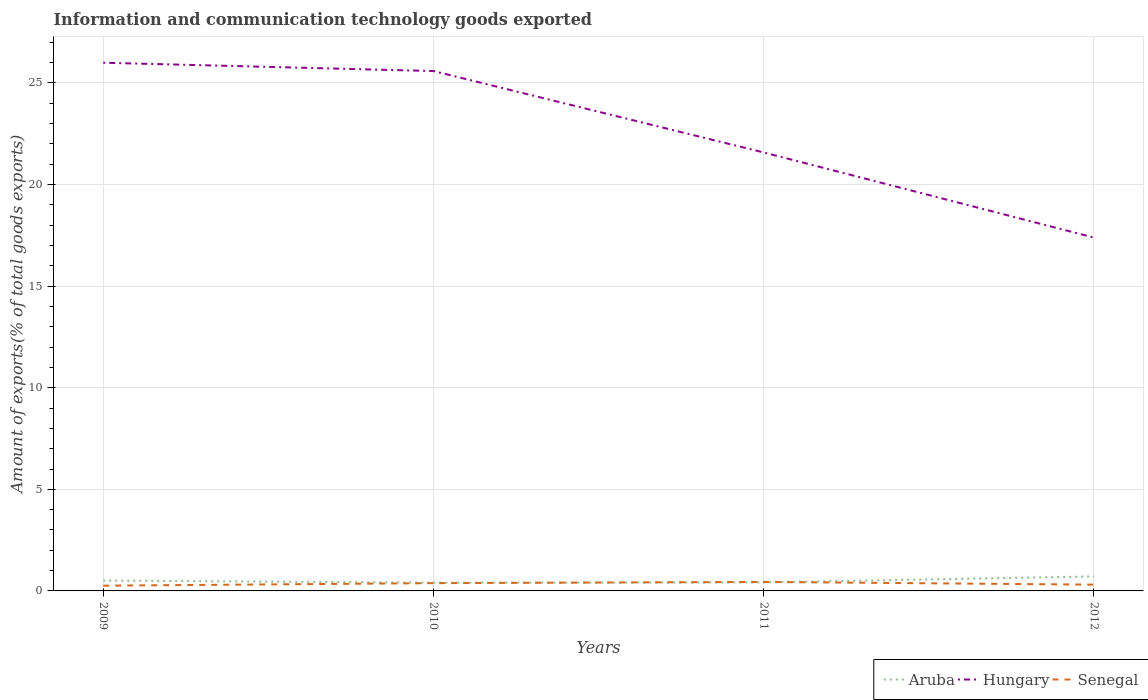How many different coloured lines are there?
Your response must be concise. 3. Does the line corresponding to Aruba intersect with the line corresponding to Hungary?
Ensure brevity in your answer.  No. Is the number of lines equal to the number of legend labels?
Offer a terse response. Yes. Across all years, what is the maximum amount of goods exported in Senegal?
Keep it short and to the point. 0.26. In which year was the amount of goods exported in Senegal maximum?
Ensure brevity in your answer.  2009. What is the total amount of goods exported in Hungary in the graph?
Make the answer very short. 0.41. What is the difference between the highest and the second highest amount of goods exported in Senegal?
Your answer should be compact. 0.18. What is the difference between the highest and the lowest amount of goods exported in Hungary?
Offer a very short reply. 2. How many years are there in the graph?
Your answer should be compact. 4. Does the graph contain any zero values?
Offer a terse response. No. Where does the legend appear in the graph?
Your answer should be compact. Bottom right. How are the legend labels stacked?
Offer a very short reply. Horizontal. What is the title of the graph?
Offer a terse response. Information and communication technology goods exported. What is the label or title of the Y-axis?
Your response must be concise. Amount of exports(% of total goods exports). What is the Amount of exports(% of total goods exports) in Aruba in 2009?
Provide a short and direct response. 0.51. What is the Amount of exports(% of total goods exports) of Hungary in 2009?
Your answer should be compact. 26. What is the Amount of exports(% of total goods exports) in Senegal in 2009?
Make the answer very short. 0.26. What is the Amount of exports(% of total goods exports) in Aruba in 2010?
Offer a very short reply. 0.4. What is the Amount of exports(% of total goods exports) of Hungary in 2010?
Ensure brevity in your answer.  25.59. What is the Amount of exports(% of total goods exports) of Senegal in 2010?
Make the answer very short. 0.38. What is the Amount of exports(% of total goods exports) in Aruba in 2011?
Your answer should be very brief. 0.42. What is the Amount of exports(% of total goods exports) of Hungary in 2011?
Provide a short and direct response. 21.58. What is the Amount of exports(% of total goods exports) of Senegal in 2011?
Your answer should be very brief. 0.44. What is the Amount of exports(% of total goods exports) of Aruba in 2012?
Provide a succinct answer. 0.71. What is the Amount of exports(% of total goods exports) of Hungary in 2012?
Your answer should be compact. 17.39. What is the Amount of exports(% of total goods exports) of Senegal in 2012?
Provide a short and direct response. 0.31. Across all years, what is the maximum Amount of exports(% of total goods exports) in Aruba?
Your answer should be very brief. 0.71. Across all years, what is the maximum Amount of exports(% of total goods exports) of Hungary?
Your answer should be very brief. 26. Across all years, what is the maximum Amount of exports(% of total goods exports) in Senegal?
Your response must be concise. 0.44. Across all years, what is the minimum Amount of exports(% of total goods exports) of Aruba?
Provide a short and direct response. 0.4. Across all years, what is the minimum Amount of exports(% of total goods exports) in Hungary?
Provide a succinct answer. 17.39. Across all years, what is the minimum Amount of exports(% of total goods exports) in Senegal?
Provide a short and direct response. 0.26. What is the total Amount of exports(% of total goods exports) of Aruba in the graph?
Your answer should be very brief. 2.05. What is the total Amount of exports(% of total goods exports) of Hungary in the graph?
Your response must be concise. 90.55. What is the total Amount of exports(% of total goods exports) of Senegal in the graph?
Give a very brief answer. 1.39. What is the difference between the Amount of exports(% of total goods exports) in Aruba in 2009 and that in 2010?
Provide a short and direct response. 0.11. What is the difference between the Amount of exports(% of total goods exports) in Hungary in 2009 and that in 2010?
Your answer should be compact. 0.41. What is the difference between the Amount of exports(% of total goods exports) in Senegal in 2009 and that in 2010?
Provide a succinct answer. -0.12. What is the difference between the Amount of exports(% of total goods exports) in Aruba in 2009 and that in 2011?
Your answer should be compact. 0.09. What is the difference between the Amount of exports(% of total goods exports) in Hungary in 2009 and that in 2011?
Provide a short and direct response. 4.42. What is the difference between the Amount of exports(% of total goods exports) in Senegal in 2009 and that in 2011?
Ensure brevity in your answer.  -0.18. What is the difference between the Amount of exports(% of total goods exports) in Aruba in 2009 and that in 2012?
Give a very brief answer. -0.2. What is the difference between the Amount of exports(% of total goods exports) of Hungary in 2009 and that in 2012?
Offer a terse response. 8.61. What is the difference between the Amount of exports(% of total goods exports) in Senegal in 2009 and that in 2012?
Offer a very short reply. -0.05. What is the difference between the Amount of exports(% of total goods exports) of Aruba in 2010 and that in 2011?
Make the answer very short. -0.02. What is the difference between the Amount of exports(% of total goods exports) in Hungary in 2010 and that in 2011?
Your answer should be compact. 4.01. What is the difference between the Amount of exports(% of total goods exports) of Senegal in 2010 and that in 2011?
Provide a short and direct response. -0.06. What is the difference between the Amount of exports(% of total goods exports) in Aruba in 2010 and that in 2012?
Provide a succinct answer. -0.31. What is the difference between the Amount of exports(% of total goods exports) in Hungary in 2010 and that in 2012?
Ensure brevity in your answer.  8.2. What is the difference between the Amount of exports(% of total goods exports) in Senegal in 2010 and that in 2012?
Make the answer very short. 0.07. What is the difference between the Amount of exports(% of total goods exports) of Aruba in 2011 and that in 2012?
Give a very brief answer. -0.29. What is the difference between the Amount of exports(% of total goods exports) of Hungary in 2011 and that in 2012?
Offer a terse response. 4.19. What is the difference between the Amount of exports(% of total goods exports) of Senegal in 2011 and that in 2012?
Ensure brevity in your answer.  0.13. What is the difference between the Amount of exports(% of total goods exports) of Aruba in 2009 and the Amount of exports(% of total goods exports) of Hungary in 2010?
Provide a short and direct response. -25.08. What is the difference between the Amount of exports(% of total goods exports) of Aruba in 2009 and the Amount of exports(% of total goods exports) of Senegal in 2010?
Offer a terse response. 0.13. What is the difference between the Amount of exports(% of total goods exports) in Hungary in 2009 and the Amount of exports(% of total goods exports) in Senegal in 2010?
Offer a very short reply. 25.61. What is the difference between the Amount of exports(% of total goods exports) in Aruba in 2009 and the Amount of exports(% of total goods exports) in Hungary in 2011?
Give a very brief answer. -21.07. What is the difference between the Amount of exports(% of total goods exports) of Aruba in 2009 and the Amount of exports(% of total goods exports) of Senegal in 2011?
Keep it short and to the point. 0.07. What is the difference between the Amount of exports(% of total goods exports) of Hungary in 2009 and the Amount of exports(% of total goods exports) of Senegal in 2011?
Offer a terse response. 25.55. What is the difference between the Amount of exports(% of total goods exports) in Aruba in 2009 and the Amount of exports(% of total goods exports) in Hungary in 2012?
Provide a succinct answer. -16.88. What is the difference between the Amount of exports(% of total goods exports) in Aruba in 2009 and the Amount of exports(% of total goods exports) in Senegal in 2012?
Your answer should be compact. 0.2. What is the difference between the Amount of exports(% of total goods exports) in Hungary in 2009 and the Amount of exports(% of total goods exports) in Senegal in 2012?
Keep it short and to the point. 25.69. What is the difference between the Amount of exports(% of total goods exports) in Aruba in 2010 and the Amount of exports(% of total goods exports) in Hungary in 2011?
Make the answer very short. -21.17. What is the difference between the Amount of exports(% of total goods exports) of Aruba in 2010 and the Amount of exports(% of total goods exports) of Senegal in 2011?
Provide a short and direct response. -0.04. What is the difference between the Amount of exports(% of total goods exports) in Hungary in 2010 and the Amount of exports(% of total goods exports) in Senegal in 2011?
Your answer should be very brief. 25.14. What is the difference between the Amount of exports(% of total goods exports) of Aruba in 2010 and the Amount of exports(% of total goods exports) of Hungary in 2012?
Offer a very short reply. -16.98. What is the difference between the Amount of exports(% of total goods exports) of Aruba in 2010 and the Amount of exports(% of total goods exports) of Senegal in 2012?
Provide a short and direct response. 0.1. What is the difference between the Amount of exports(% of total goods exports) of Hungary in 2010 and the Amount of exports(% of total goods exports) of Senegal in 2012?
Your answer should be very brief. 25.28. What is the difference between the Amount of exports(% of total goods exports) in Aruba in 2011 and the Amount of exports(% of total goods exports) in Hungary in 2012?
Offer a terse response. -16.97. What is the difference between the Amount of exports(% of total goods exports) in Aruba in 2011 and the Amount of exports(% of total goods exports) in Senegal in 2012?
Keep it short and to the point. 0.11. What is the difference between the Amount of exports(% of total goods exports) in Hungary in 2011 and the Amount of exports(% of total goods exports) in Senegal in 2012?
Keep it short and to the point. 21.27. What is the average Amount of exports(% of total goods exports) of Aruba per year?
Ensure brevity in your answer.  0.51. What is the average Amount of exports(% of total goods exports) of Hungary per year?
Provide a short and direct response. 22.64. What is the average Amount of exports(% of total goods exports) of Senegal per year?
Keep it short and to the point. 0.35. In the year 2009, what is the difference between the Amount of exports(% of total goods exports) of Aruba and Amount of exports(% of total goods exports) of Hungary?
Provide a short and direct response. -25.49. In the year 2009, what is the difference between the Amount of exports(% of total goods exports) of Aruba and Amount of exports(% of total goods exports) of Senegal?
Give a very brief answer. 0.25. In the year 2009, what is the difference between the Amount of exports(% of total goods exports) of Hungary and Amount of exports(% of total goods exports) of Senegal?
Provide a short and direct response. 25.74. In the year 2010, what is the difference between the Amount of exports(% of total goods exports) in Aruba and Amount of exports(% of total goods exports) in Hungary?
Offer a very short reply. -25.18. In the year 2010, what is the difference between the Amount of exports(% of total goods exports) in Aruba and Amount of exports(% of total goods exports) in Senegal?
Provide a short and direct response. 0.02. In the year 2010, what is the difference between the Amount of exports(% of total goods exports) in Hungary and Amount of exports(% of total goods exports) in Senegal?
Provide a succinct answer. 25.2. In the year 2011, what is the difference between the Amount of exports(% of total goods exports) in Aruba and Amount of exports(% of total goods exports) in Hungary?
Provide a short and direct response. -21.16. In the year 2011, what is the difference between the Amount of exports(% of total goods exports) of Aruba and Amount of exports(% of total goods exports) of Senegal?
Ensure brevity in your answer.  -0.02. In the year 2011, what is the difference between the Amount of exports(% of total goods exports) in Hungary and Amount of exports(% of total goods exports) in Senegal?
Your response must be concise. 21.14. In the year 2012, what is the difference between the Amount of exports(% of total goods exports) of Aruba and Amount of exports(% of total goods exports) of Hungary?
Make the answer very short. -16.68. In the year 2012, what is the difference between the Amount of exports(% of total goods exports) of Aruba and Amount of exports(% of total goods exports) of Senegal?
Ensure brevity in your answer.  0.4. In the year 2012, what is the difference between the Amount of exports(% of total goods exports) of Hungary and Amount of exports(% of total goods exports) of Senegal?
Your response must be concise. 17.08. What is the ratio of the Amount of exports(% of total goods exports) of Aruba in 2009 to that in 2010?
Your response must be concise. 1.26. What is the ratio of the Amount of exports(% of total goods exports) of Senegal in 2009 to that in 2010?
Ensure brevity in your answer.  0.68. What is the ratio of the Amount of exports(% of total goods exports) of Aruba in 2009 to that in 2011?
Provide a short and direct response. 1.21. What is the ratio of the Amount of exports(% of total goods exports) of Hungary in 2009 to that in 2011?
Give a very brief answer. 1.2. What is the ratio of the Amount of exports(% of total goods exports) in Senegal in 2009 to that in 2011?
Give a very brief answer. 0.58. What is the ratio of the Amount of exports(% of total goods exports) of Aruba in 2009 to that in 2012?
Give a very brief answer. 0.71. What is the ratio of the Amount of exports(% of total goods exports) of Hungary in 2009 to that in 2012?
Offer a terse response. 1.49. What is the ratio of the Amount of exports(% of total goods exports) in Senegal in 2009 to that in 2012?
Give a very brief answer. 0.84. What is the ratio of the Amount of exports(% of total goods exports) of Aruba in 2010 to that in 2011?
Provide a succinct answer. 0.96. What is the ratio of the Amount of exports(% of total goods exports) of Hungary in 2010 to that in 2011?
Provide a succinct answer. 1.19. What is the ratio of the Amount of exports(% of total goods exports) in Senegal in 2010 to that in 2011?
Give a very brief answer. 0.86. What is the ratio of the Amount of exports(% of total goods exports) in Aruba in 2010 to that in 2012?
Provide a short and direct response. 0.57. What is the ratio of the Amount of exports(% of total goods exports) in Hungary in 2010 to that in 2012?
Offer a very short reply. 1.47. What is the ratio of the Amount of exports(% of total goods exports) of Senegal in 2010 to that in 2012?
Make the answer very short. 1.24. What is the ratio of the Amount of exports(% of total goods exports) of Aruba in 2011 to that in 2012?
Your answer should be compact. 0.59. What is the ratio of the Amount of exports(% of total goods exports) of Hungary in 2011 to that in 2012?
Provide a succinct answer. 1.24. What is the ratio of the Amount of exports(% of total goods exports) in Senegal in 2011 to that in 2012?
Your answer should be very brief. 1.43. What is the difference between the highest and the second highest Amount of exports(% of total goods exports) in Aruba?
Provide a short and direct response. 0.2. What is the difference between the highest and the second highest Amount of exports(% of total goods exports) in Hungary?
Your response must be concise. 0.41. What is the difference between the highest and the second highest Amount of exports(% of total goods exports) of Senegal?
Keep it short and to the point. 0.06. What is the difference between the highest and the lowest Amount of exports(% of total goods exports) in Aruba?
Keep it short and to the point. 0.31. What is the difference between the highest and the lowest Amount of exports(% of total goods exports) of Hungary?
Provide a succinct answer. 8.61. What is the difference between the highest and the lowest Amount of exports(% of total goods exports) in Senegal?
Your answer should be very brief. 0.18. 